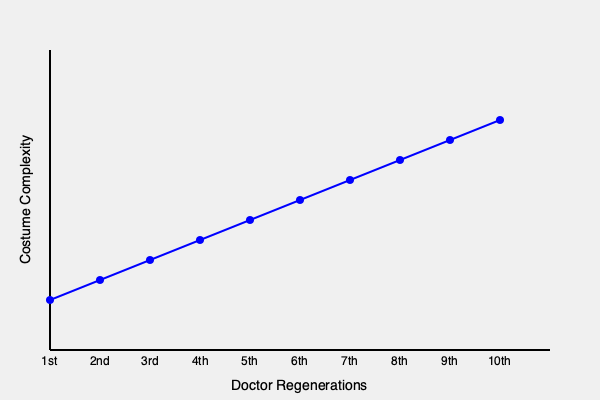Analyzing the graph depicting the evolution of the Doctor's costume complexity across regenerations, which mathematical function best describes the trend, and how does this relate to the show's production values and character development over time? To answer this question, we need to follow these steps:

1. Observe the trend in the graph:
   The line shows a consistent upward trend from the 1st to the 10th Doctor.

2. Analyze the shape of the curve:
   The curve appears to be relatively straight, with a constant rate of increase.

3. Identify the mathematical function:
   Given the constant rate of increase, the trend most closely resembles a linear function.

4. Express the linear function mathematically:
   The general form of a linear function is $y = mx + b$, where $m$ is the slope and $b$ is the y-intercept.

5. Relate to production values:
   The increasing complexity of costumes likely reflects:
   a) Higher budgets for costume design over time
   b) Advancements in fabric technology and costume-making techniques
   c) Increased attention to visual details in television production

6. Connect to character development:
   The evolution in costume complexity might indicate:
   a) More nuanced and multifaceted character portrayals
   b) A desire to visually distinguish each Doctor's unique personality
   c) Reflection of the Doctor's growing complexity and accumulated experiences

7. Consider the show's historical context:
   The trend aligns with the general evolution of television production values from the 1960s to the modern era.

Therefore, the costume complexity trend can be described by a linear function, reflecting both the show's increasing production values and the character's evolving complexity over time.
Answer: Linear function ($y = mx + b$); reflects increasing production values and character complexity 